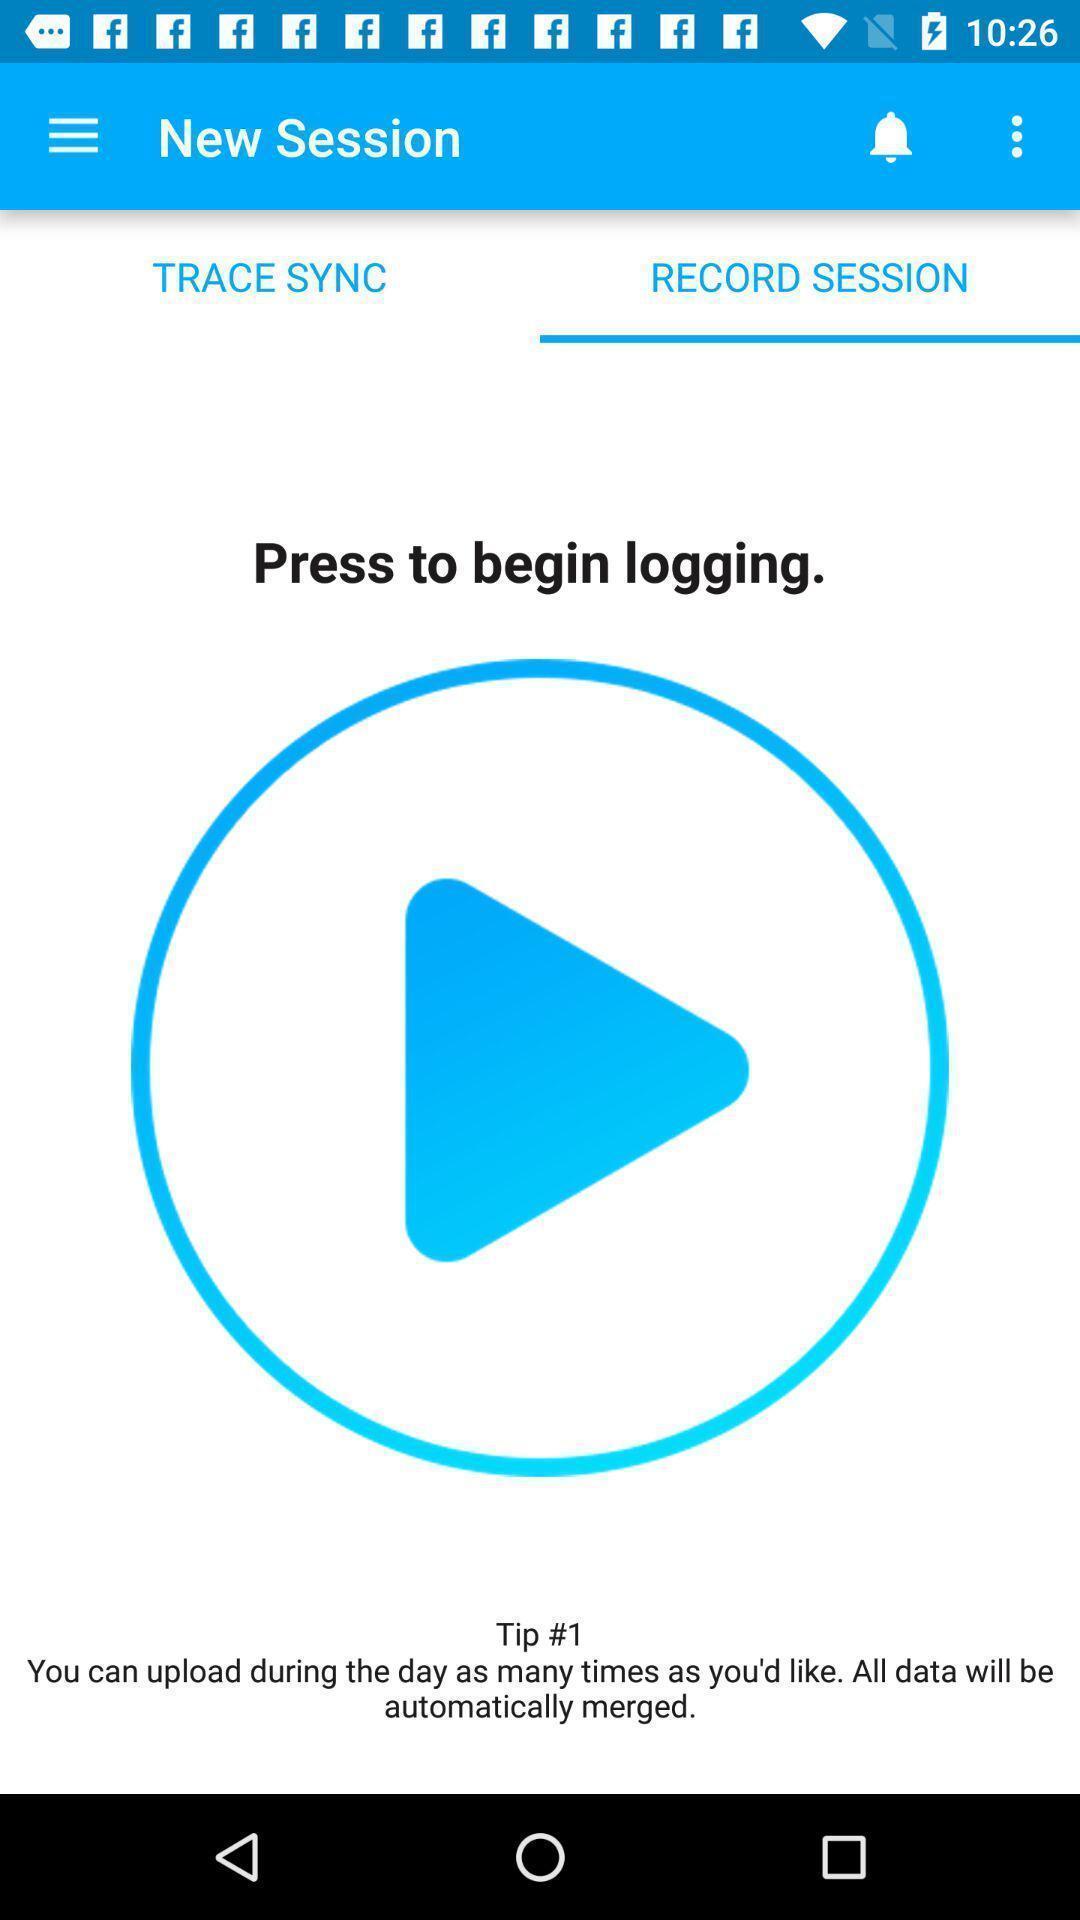Give me a narrative description of this picture. Page for recording a session of winter sport app. 